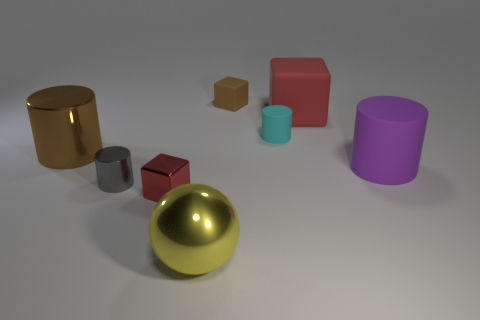Subtract all small gray metallic cylinders. How many cylinders are left? 3 Subtract all balls. How many objects are left? 7 Add 1 small cyan metallic cylinders. How many objects exist? 9 Subtract 2 cylinders. How many cylinders are left? 2 Subtract all cyan balls. Subtract all green cubes. How many balls are left? 1 Subtract all red cylinders. How many brown cubes are left? 1 Subtract all metallic things. Subtract all gray rubber things. How many objects are left? 4 Add 8 brown matte blocks. How many brown matte blocks are left? 9 Add 2 big brown rubber objects. How many big brown rubber objects exist? 2 Subtract all purple cylinders. How many cylinders are left? 3 